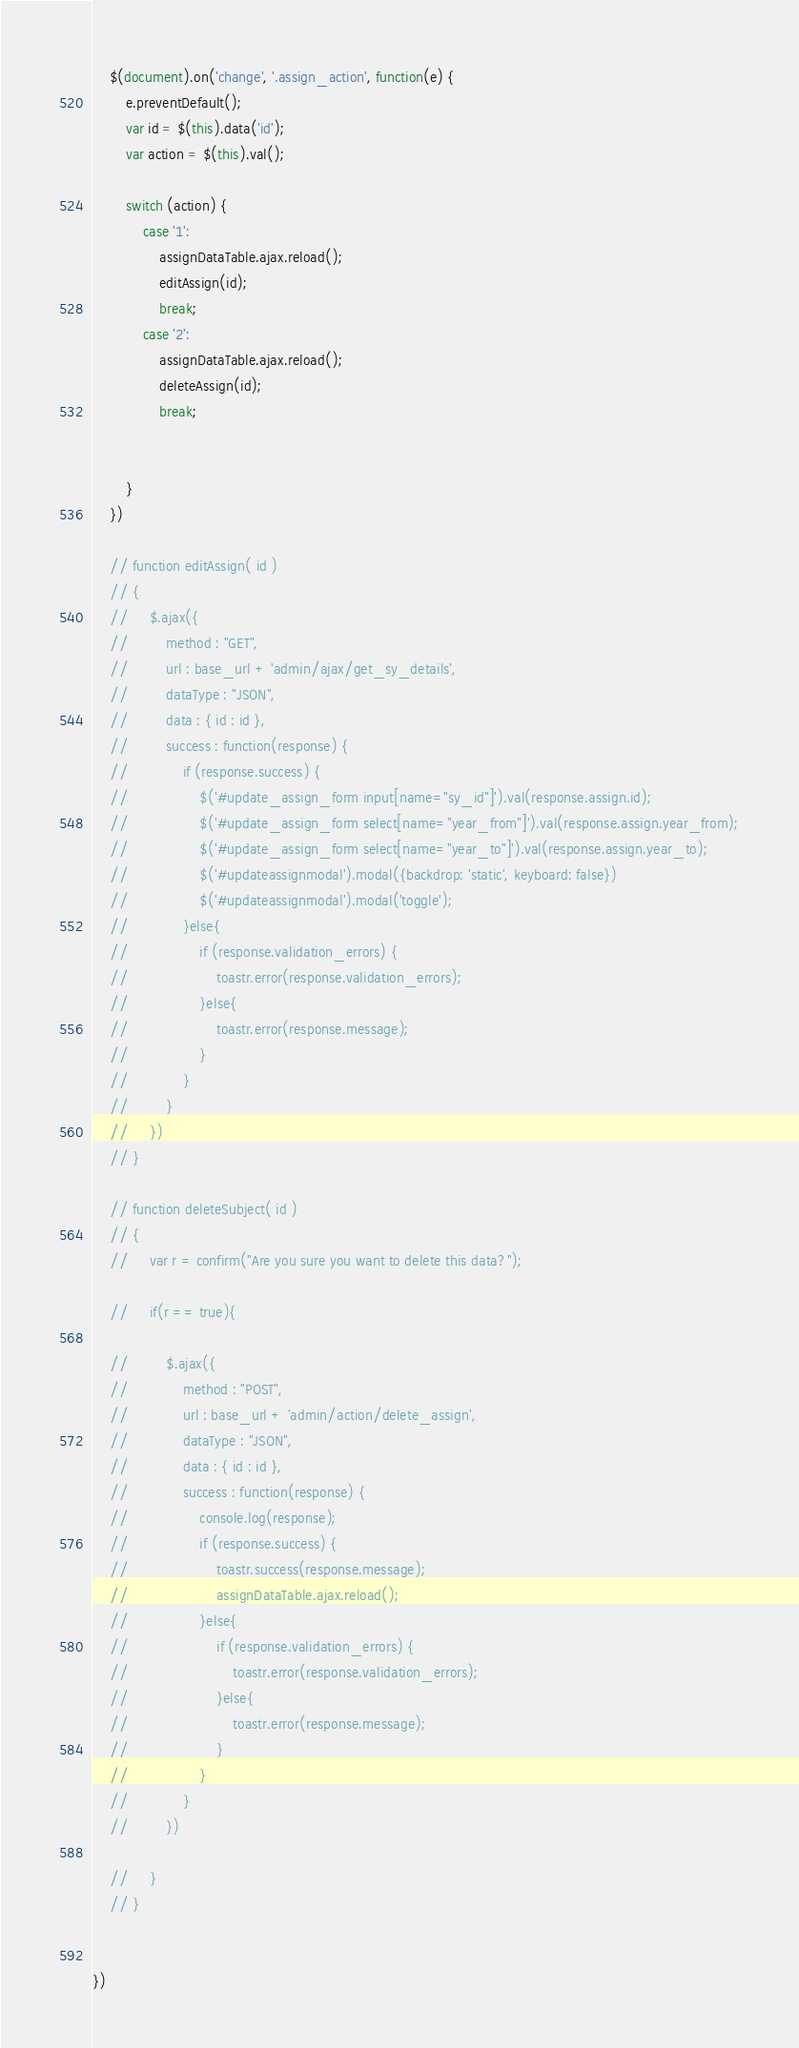Convert code to text. <code><loc_0><loc_0><loc_500><loc_500><_JavaScript_>
    $(document).on('change', '.assign_action', function(e) {
        e.preventDefault();
        var id = $(this).data('id');
        var action = $(this).val();
        
        switch (action) {
            case '1':
                assignDataTable.ajax.reload();
                editAssign(id);
                break;
            case '2':
                assignDataTable.ajax.reload();
                deleteAssign(id);
                break;
        
            
        }
    })

    // function editAssign( id )
    // {
    //     $.ajax({
    //         method : "GET",
    //         url : base_url + 'admin/ajax/get_sy_details',
    //         dataType : "JSON",
    //         data : { id : id },
    //         success : function(response) {
    //             if (response.success) {
    //                 $('#update_assign_form input[name="sy_id"]').val(response.assign.id);
    //                 $('#update_assign_form select[name="year_from"]').val(response.assign.year_from);
    //                 $('#update_assign_form select[name="year_to"]').val(response.assign.year_to);
    //                 $('#updateassignmodal').modal({backdrop: 'static', keyboard: false})
    //                 $('#updateassignmodal').modal('toggle');
    //             }else{
    //                 if (response.validation_errors) {
    //                     toastr.error(response.validation_errors);
    //                 }else{
    //                     toastr.error(response.message);
    //                 }
    //             }
    //         }
    //     })
    // }

    // function deleteSubject( id )
    // {
    //     var r = confirm("Are you sure you want to delete this data?");

    //     if(r == true){

    //         $.ajax({
    //             method : "POST",
    //             url : base_url + 'admin/action/delete_assign',
    //             dataType : "JSON",
    //             data : { id : id },
    //             success : function(response) {
    //                 console.log(response);
    //                 if (response.success) {
    //                     toastr.success(response.message);
    //                     assignDataTable.ajax.reload();
    //                 }else{
    //                     if (response.validation_errors) {
    //                         toastr.error(response.validation_errors);
    //                     }else{
    //                         toastr.error(response.message);
    //                     }
    //                 }
    //             }
    //         })

    //     }
    // }


})</code> 